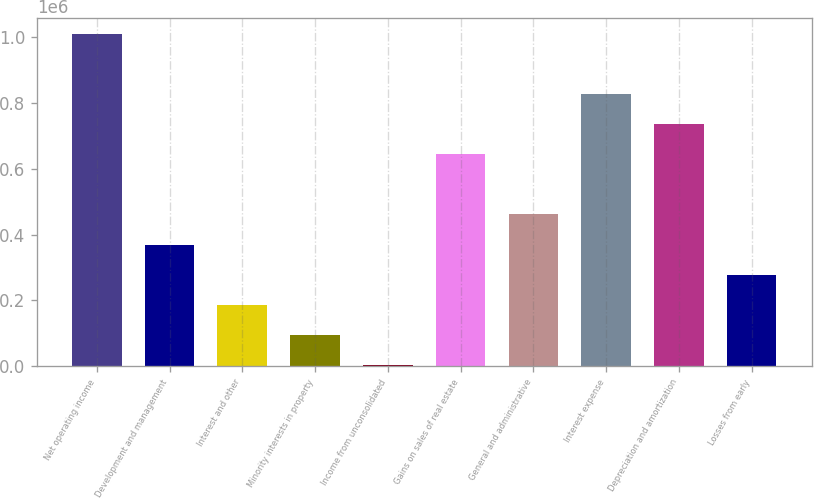<chart> <loc_0><loc_0><loc_500><loc_500><bar_chart><fcel>Net operating income<fcel>Development and management<fcel>Interest and other<fcel>Minority interests in property<fcel>Income from unconsolidated<fcel>Gains on sales of real estate<fcel>General and administrative<fcel>Interest expense<fcel>Depreciation and amortization<fcel>Losses from early<nl><fcel>1.00963e+06<fcel>370212<fcel>187520<fcel>96174.7<fcel>4829<fcel>644249<fcel>461558<fcel>826940<fcel>735595<fcel>278866<nl></chart> 